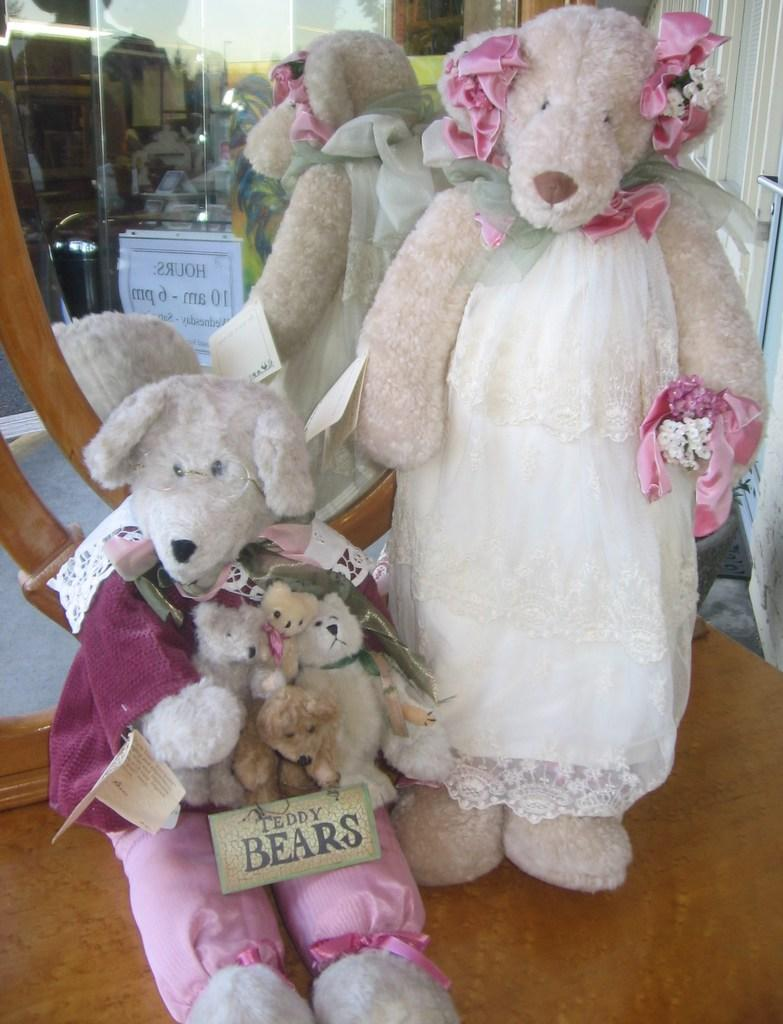How many teddy bears are present in the image? There are two teddy bears in the image. What can be seen in the background of the image? There is a mirror in the background of the image. What is located on the right side of the image? There is a curtain on the right side of the image. How much sugar is on the teddy bears in the image? There is no sugar present on the teddy bears in the image. Can you see any wounds on the teddy bears in the image? There are no wounds visible on the teddy bears in the image. 